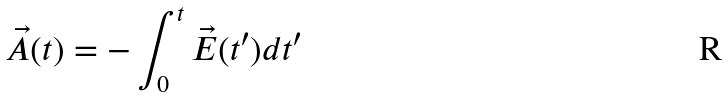Convert formula to latex. <formula><loc_0><loc_0><loc_500><loc_500>\vec { A } ( t ) = - \int _ { 0 } ^ { t } \vec { E } ( t ^ { \prime } ) d t ^ { \prime }</formula> 